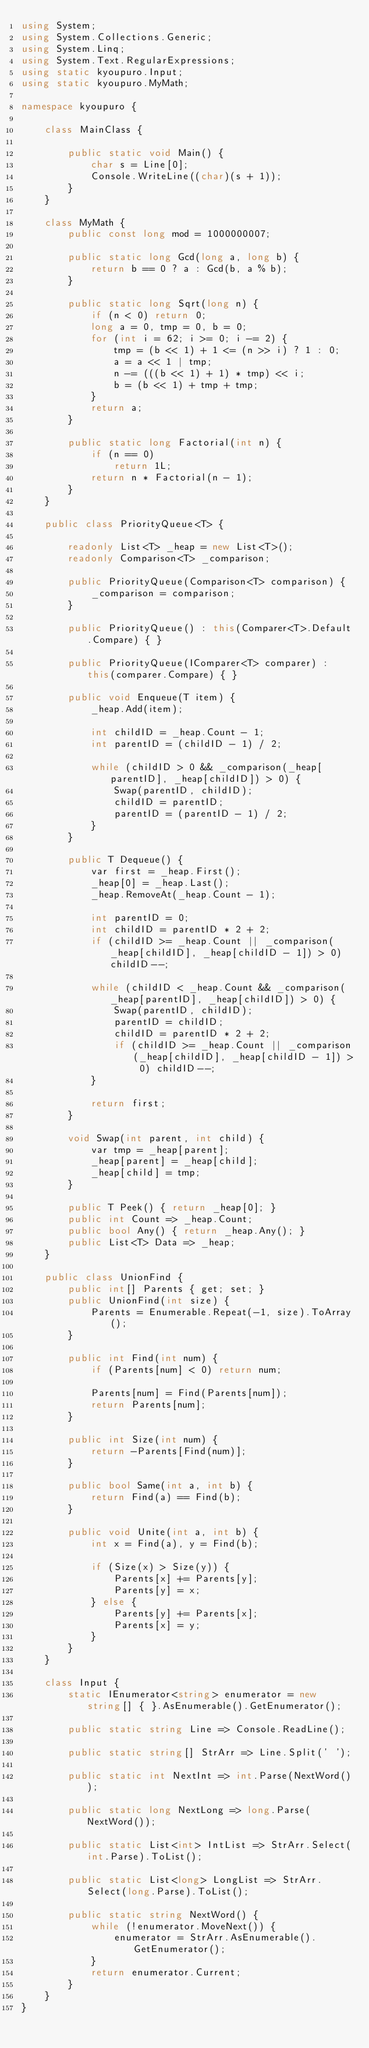Convert code to text. <code><loc_0><loc_0><loc_500><loc_500><_C#_>using System;
using System.Collections.Generic;
using System.Linq;
using System.Text.RegularExpressions;
using static kyoupuro.Input;
using static kyoupuro.MyMath;

namespace kyoupuro {

    class MainClass {

        public static void Main() {
            char s = Line[0];
            Console.WriteLine((char)(s + 1));
        }
    }

    class MyMath {
        public const long mod = 1000000007;

        public static long Gcd(long a, long b) {
            return b == 0 ? a : Gcd(b, a % b);
        }

        public static long Sqrt(long n) {
            if (n < 0) return 0;
            long a = 0, tmp = 0, b = 0;
            for (int i = 62; i >= 0; i -= 2) {
                tmp = (b << 1) + 1 <= (n >> i) ? 1 : 0;
                a = a << 1 | tmp;
                n -= (((b << 1) + 1) * tmp) << i;
                b = (b << 1) + tmp + tmp;
            }
            return a;
        }

        public static long Factorial(int n) {
            if (n == 0)
                return 1L;
            return n * Factorial(n - 1);
        }
    }

    public class PriorityQueue<T> {

        readonly List<T> _heap = new List<T>();
        readonly Comparison<T> _comparison;

        public PriorityQueue(Comparison<T> comparison) {
            _comparison = comparison;
        }

        public PriorityQueue() : this(Comparer<T>.Default.Compare) { }

        public PriorityQueue(IComparer<T> comparer) : this(comparer.Compare) { }

        public void Enqueue(T item) {
            _heap.Add(item);

            int childID = _heap.Count - 1;
            int parentID = (childID - 1) / 2;

            while (childID > 0 && _comparison(_heap[parentID], _heap[childID]) > 0) {
                Swap(parentID, childID);
                childID = parentID;
                parentID = (parentID - 1) / 2;
            }
        }

        public T Dequeue() {
            var first = _heap.First();
            _heap[0] = _heap.Last();
            _heap.RemoveAt(_heap.Count - 1);

            int parentID = 0;
            int childID = parentID * 2 + 2;
            if (childID >= _heap.Count || _comparison(_heap[childID], _heap[childID - 1]) > 0) childID--;

            while (childID < _heap.Count && _comparison(_heap[parentID], _heap[childID]) > 0) {
                Swap(parentID, childID);
                parentID = childID;
                childID = parentID * 2 + 2;
                if (childID >= _heap.Count || _comparison(_heap[childID], _heap[childID - 1]) > 0) childID--;
            }

            return first;
        }

        void Swap(int parent, int child) {
            var tmp = _heap[parent];
            _heap[parent] = _heap[child];
            _heap[child] = tmp;
        }

        public T Peek() { return _heap[0]; }
        public int Count => _heap.Count;
        public bool Any() { return _heap.Any(); }
        public List<T> Data => _heap;
    }

    public class UnionFind {
        public int[] Parents { get; set; }
        public UnionFind(int size) {
            Parents = Enumerable.Repeat(-1, size).ToArray();
        }

        public int Find(int num) {
            if (Parents[num] < 0) return num;

            Parents[num] = Find(Parents[num]);
            return Parents[num];
        }

        public int Size(int num) {
            return -Parents[Find(num)];
        }

        public bool Same(int a, int b) {
            return Find(a) == Find(b);
        }

        public void Unite(int a, int b) {
            int x = Find(a), y = Find(b);

            if (Size(x) > Size(y)) {
                Parents[x] += Parents[y];
                Parents[y] = x;
            } else {
                Parents[y] += Parents[x];
                Parents[x] = y;
            }
        }
    }

    class Input {
        static IEnumerator<string> enumerator = new string[] { }.AsEnumerable().GetEnumerator();

        public static string Line => Console.ReadLine();

        public static string[] StrArr => Line.Split(' ');

        public static int NextInt => int.Parse(NextWord());

        public static long NextLong => long.Parse(NextWord());

        public static List<int> IntList => StrArr.Select(int.Parse).ToList();

        public static List<long> LongList => StrArr.Select(long.Parse).ToList();

        public static string NextWord() {
            while (!enumerator.MoveNext()) {
                enumerator = StrArr.AsEnumerable().GetEnumerator();
            }
            return enumerator.Current;
        }
    }
}</code> 